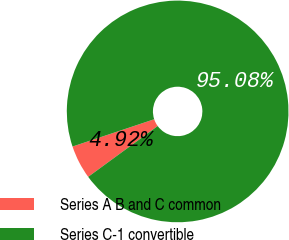Convert chart. <chart><loc_0><loc_0><loc_500><loc_500><pie_chart><fcel>Series A B and C common<fcel>Series C-1 convertible<nl><fcel>4.92%<fcel>95.08%<nl></chart> 